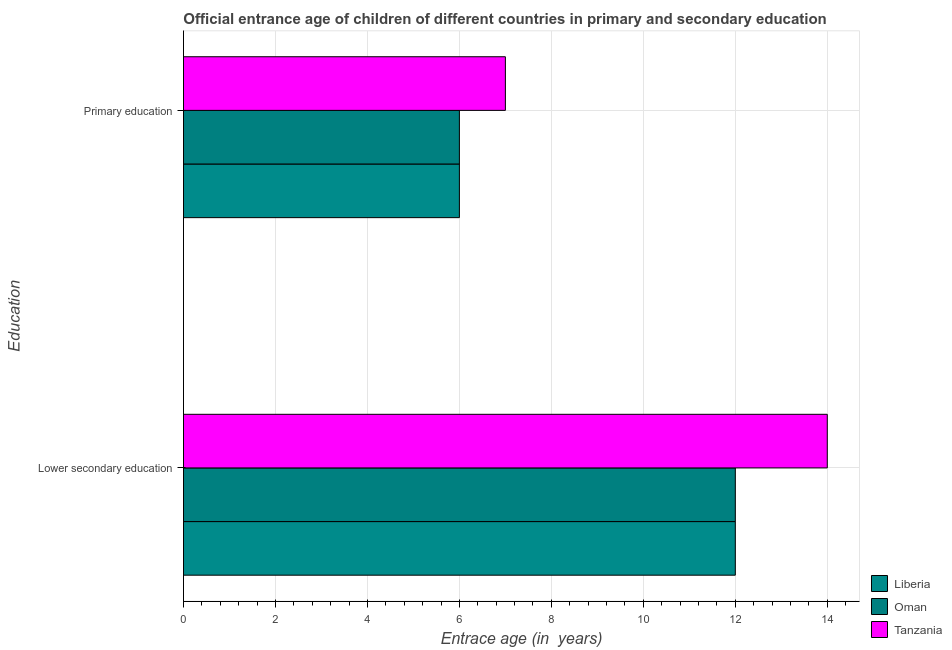Are the number of bars per tick equal to the number of legend labels?
Make the answer very short. Yes. Are the number of bars on each tick of the Y-axis equal?
Offer a very short reply. Yes. How many bars are there on the 1st tick from the top?
Provide a succinct answer. 3. What is the entrance age of chiildren in primary education in Tanzania?
Offer a terse response. 7. Across all countries, what is the maximum entrance age of chiildren in primary education?
Give a very brief answer. 7. Across all countries, what is the minimum entrance age of children in lower secondary education?
Your answer should be very brief. 12. In which country was the entrance age of children in lower secondary education maximum?
Make the answer very short. Tanzania. In which country was the entrance age of children in lower secondary education minimum?
Offer a terse response. Liberia. What is the total entrance age of children in lower secondary education in the graph?
Offer a very short reply. 38. What is the difference between the entrance age of chiildren in primary education in Oman and that in Liberia?
Give a very brief answer. 0. What is the difference between the entrance age of chiildren in primary education in Oman and the entrance age of children in lower secondary education in Tanzania?
Your answer should be very brief. -8. What is the average entrance age of chiildren in primary education per country?
Your answer should be compact. 6.33. What is the difference between the entrance age of children in lower secondary education and entrance age of chiildren in primary education in Oman?
Provide a short and direct response. 6. In how many countries, is the entrance age of children in lower secondary education greater than 3.2 years?
Offer a very short reply. 3. What is the ratio of the entrance age of chiildren in primary education in Oman to that in Liberia?
Make the answer very short. 1. Is the entrance age of children in lower secondary education in Tanzania less than that in Liberia?
Offer a terse response. No. In how many countries, is the entrance age of chiildren in primary education greater than the average entrance age of chiildren in primary education taken over all countries?
Your answer should be very brief. 1. What does the 1st bar from the top in Primary education represents?
Your answer should be very brief. Tanzania. What does the 2nd bar from the bottom in Primary education represents?
Provide a short and direct response. Oman. How many bars are there?
Your response must be concise. 6. How many countries are there in the graph?
Provide a succinct answer. 3. What is the difference between two consecutive major ticks on the X-axis?
Offer a terse response. 2. Does the graph contain any zero values?
Make the answer very short. No. Does the graph contain grids?
Your answer should be compact. Yes. Where does the legend appear in the graph?
Give a very brief answer. Bottom right. What is the title of the graph?
Give a very brief answer. Official entrance age of children of different countries in primary and secondary education. Does "Korea (Democratic)" appear as one of the legend labels in the graph?
Keep it short and to the point. No. What is the label or title of the X-axis?
Offer a very short reply. Entrace age (in  years). What is the label or title of the Y-axis?
Your response must be concise. Education. What is the Entrace age (in  years) in Liberia in Lower secondary education?
Make the answer very short. 12. What is the Entrace age (in  years) in Oman in Lower secondary education?
Provide a succinct answer. 12. What is the Entrace age (in  years) in Tanzania in Lower secondary education?
Provide a short and direct response. 14. What is the Entrace age (in  years) in Liberia in Primary education?
Keep it short and to the point. 6. What is the Entrace age (in  years) of Oman in Primary education?
Ensure brevity in your answer.  6. Across all Education, what is the maximum Entrace age (in  years) in Tanzania?
Make the answer very short. 14. Across all Education, what is the minimum Entrace age (in  years) in Tanzania?
Provide a short and direct response. 7. What is the total Entrace age (in  years) of Liberia in the graph?
Give a very brief answer. 18. What is the difference between the Entrace age (in  years) of Liberia in Lower secondary education and that in Primary education?
Offer a very short reply. 6. What is the difference between the Entrace age (in  years) in Oman in Lower secondary education and that in Primary education?
Keep it short and to the point. 6. What is the difference between the Entrace age (in  years) in Liberia in Lower secondary education and the Entrace age (in  years) in Oman in Primary education?
Your answer should be very brief. 6. What is the average Entrace age (in  years) of Oman per Education?
Offer a terse response. 9. What is the average Entrace age (in  years) of Tanzania per Education?
Make the answer very short. 10.5. What is the difference between the Entrace age (in  years) in Oman and Entrace age (in  years) in Tanzania in Lower secondary education?
Provide a succinct answer. -2. What is the difference between the Entrace age (in  years) of Liberia and Entrace age (in  years) of Oman in Primary education?
Your answer should be very brief. 0. What is the difference between the Entrace age (in  years) in Liberia and Entrace age (in  years) in Tanzania in Primary education?
Make the answer very short. -1. What is the ratio of the Entrace age (in  years) of Liberia in Lower secondary education to that in Primary education?
Keep it short and to the point. 2. What is the ratio of the Entrace age (in  years) of Oman in Lower secondary education to that in Primary education?
Your answer should be very brief. 2. What is the difference between the highest and the second highest Entrace age (in  years) of Liberia?
Keep it short and to the point. 6. What is the difference between the highest and the lowest Entrace age (in  years) of Tanzania?
Your answer should be very brief. 7. 